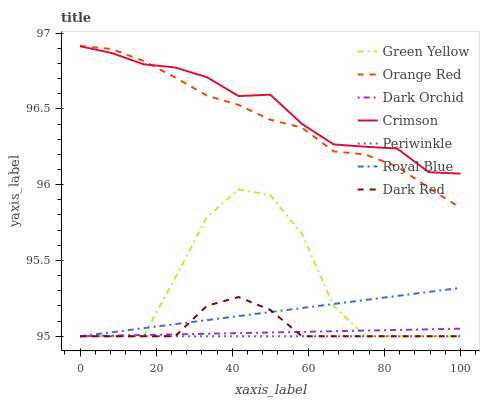Does Periwinkle have the minimum area under the curve?
Answer yes or no. Yes. Does Crimson have the maximum area under the curve?
Answer yes or no. Yes. Does Dark Orchid have the minimum area under the curve?
Answer yes or no. No. Does Dark Orchid have the maximum area under the curve?
Answer yes or no. No. Is Periwinkle the smoothest?
Answer yes or no. Yes. Is Green Yellow the roughest?
Answer yes or no. Yes. Is Dark Orchid the smoothest?
Answer yes or no. No. Is Dark Orchid the roughest?
Answer yes or no. No. Does Dark Red have the lowest value?
Answer yes or no. Yes. Does Crimson have the lowest value?
Answer yes or no. No. Does Orange Red have the highest value?
Answer yes or no. Yes. Does Dark Orchid have the highest value?
Answer yes or no. No. Is Royal Blue less than Crimson?
Answer yes or no. Yes. Is Crimson greater than Royal Blue?
Answer yes or no. Yes. Does Royal Blue intersect Dark Orchid?
Answer yes or no. Yes. Is Royal Blue less than Dark Orchid?
Answer yes or no. No. Is Royal Blue greater than Dark Orchid?
Answer yes or no. No. Does Royal Blue intersect Crimson?
Answer yes or no. No. 